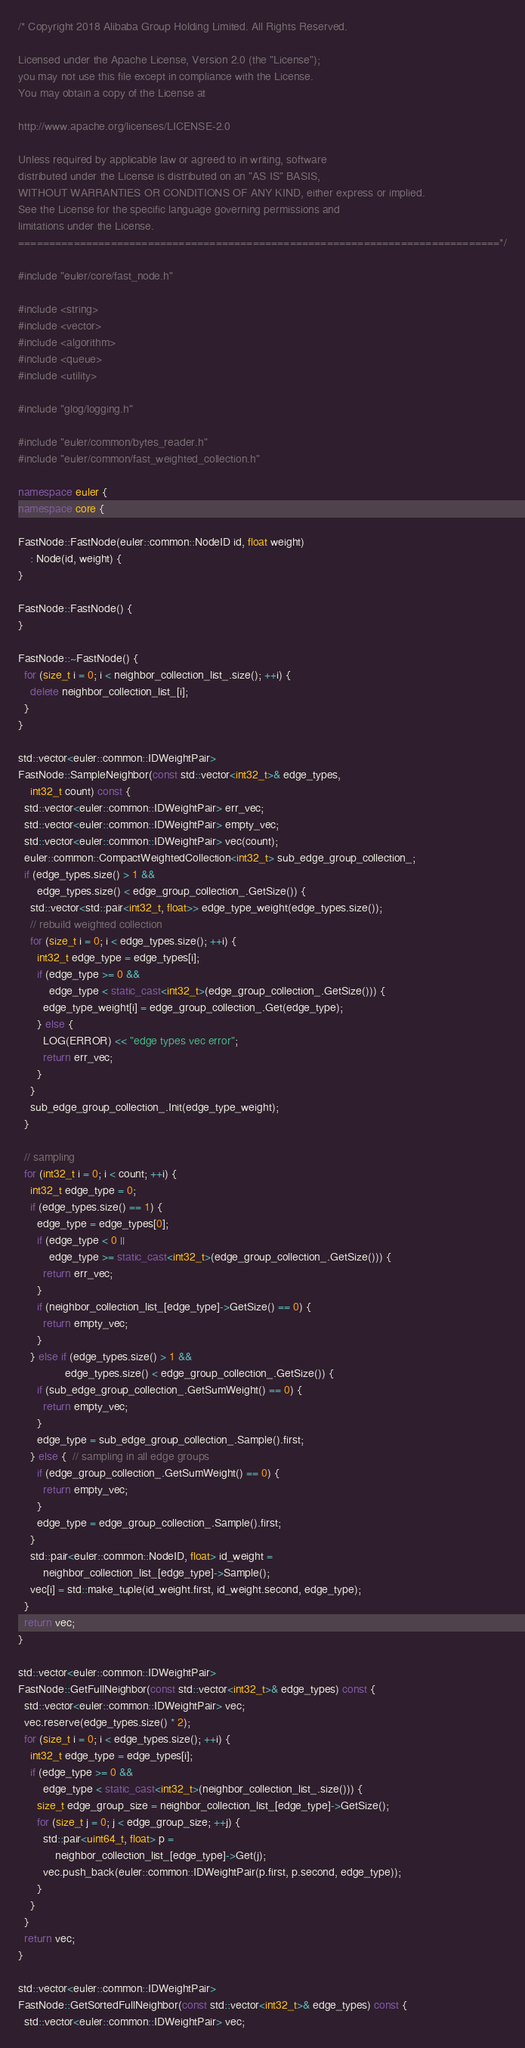Convert code to text. <code><loc_0><loc_0><loc_500><loc_500><_C++_>/* Copyright 2018 Alibaba Group Holding Limited. All Rights Reserved.

Licensed under the Apache License, Version 2.0 (the "License");
you may not use this file except in compliance with the License.
You may obtain a copy of the License at

http://www.apache.org/licenses/LICENSE-2.0

Unless required by applicable law or agreed to in writing, software
distributed under the License is distributed on an "AS IS" BASIS,
WITHOUT WARRANTIES OR CONDITIONS OF ANY KIND, either express or implied.
See the License for the specific language governing permissions and
limitations under the License.
==============================================================================*/

#include "euler/core/fast_node.h"

#include <string>
#include <vector>
#include <algorithm>
#include <queue>
#include <utility>

#include "glog/logging.h"

#include "euler/common/bytes_reader.h"
#include "euler/common/fast_weighted_collection.h"

namespace euler {
namespace core {

FastNode::FastNode(euler::common::NodeID id, float weight)
    : Node(id, weight) {
}

FastNode::FastNode() {
}

FastNode::~FastNode() {
  for (size_t i = 0; i < neighbor_collection_list_.size(); ++i) {
    delete neighbor_collection_list_[i];
  }
}

std::vector<euler::common::IDWeightPair>
FastNode::SampleNeighbor(const std::vector<int32_t>& edge_types,
    int32_t count) const {
  std::vector<euler::common::IDWeightPair> err_vec;
  std::vector<euler::common::IDWeightPair> empty_vec;
  std::vector<euler::common::IDWeightPair> vec(count);
  euler::common::CompactWeightedCollection<int32_t> sub_edge_group_collection_;
  if (edge_types.size() > 1 &&
      edge_types.size() < edge_group_collection_.GetSize()) {
    std::vector<std::pair<int32_t, float>> edge_type_weight(edge_types.size());
    // rebuild weighted collection
    for (size_t i = 0; i < edge_types.size(); ++i) {
      int32_t edge_type = edge_types[i];
      if (edge_type >= 0 &&
          edge_type < static_cast<int32_t>(edge_group_collection_.GetSize())) {
        edge_type_weight[i] = edge_group_collection_.Get(edge_type);
      } else {
        LOG(ERROR) << "edge types vec error";
        return err_vec;
      }
    }
    sub_edge_group_collection_.Init(edge_type_weight);
  }

  // sampling
  for (int32_t i = 0; i < count; ++i) {
    int32_t edge_type = 0;
    if (edge_types.size() == 1) {
      edge_type = edge_types[0];
      if (edge_type < 0 ||
          edge_type >= static_cast<int32_t>(edge_group_collection_.GetSize())) {
        return err_vec;
      }
      if (neighbor_collection_list_[edge_type]->GetSize() == 0) {
        return empty_vec;
      }
    } else if (edge_types.size() > 1 &&
               edge_types.size() < edge_group_collection_.GetSize()) {
      if (sub_edge_group_collection_.GetSumWeight() == 0) {
        return empty_vec;
      }
      edge_type = sub_edge_group_collection_.Sample().first;
    } else {  // sampling in all edge groups
      if (edge_group_collection_.GetSumWeight() == 0) {
        return empty_vec;
      }
      edge_type = edge_group_collection_.Sample().first;
    }
    std::pair<euler::common::NodeID, float> id_weight =
        neighbor_collection_list_[edge_type]->Sample();
    vec[i] = std::make_tuple(id_weight.first, id_weight.second, edge_type);
  }
  return vec;
}

std::vector<euler::common::IDWeightPair>
FastNode::GetFullNeighbor(const std::vector<int32_t>& edge_types) const {
  std::vector<euler::common::IDWeightPair> vec;
  vec.reserve(edge_types.size() * 2);
  for (size_t i = 0; i < edge_types.size(); ++i) {
    int32_t edge_type = edge_types[i];
    if (edge_type >= 0 &&
        edge_type < static_cast<int32_t>(neighbor_collection_list_.size())) {
      size_t edge_group_size = neighbor_collection_list_[edge_type]->GetSize();
      for (size_t j = 0; j < edge_group_size; ++j) {
        std::pair<uint64_t, float> p =
            neighbor_collection_list_[edge_type]->Get(j);
        vec.push_back(euler::common::IDWeightPair(p.first, p.second, edge_type));
      }
    }
  }
  return vec;
}

std::vector<euler::common::IDWeightPair>
FastNode::GetSortedFullNeighbor(const std::vector<int32_t>& edge_types) const {
  std::vector<euler::common::IDWeightPair> vec;</code> 